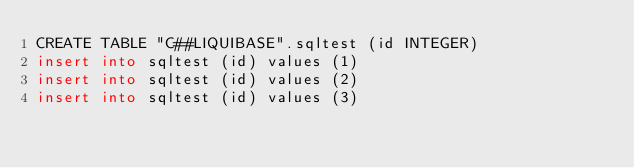<code> <loc_0><loc_0><loc_500><loc_500><_SQL_>CREATE TABLE "C##LIQUIBASE".sqltest (id INTEGER)
insert into sqltest (id) values (1)
insert into sqltest (id) values (2)
insert into sqltest (id) values (3)</code> 